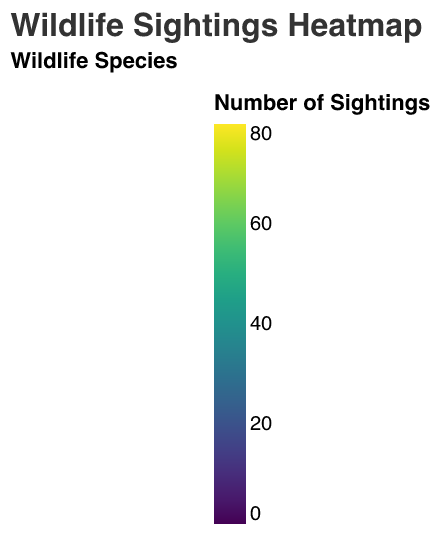What is the title of the heatmap? The title of the heatmap is displayed at the top of the figure in a larger font size, and it typically provides a summary of what the heatmap represents.
Answer: Wildlife Sightings Heatmap Which habitat zone and time of day combination has the highest number of bird sightings? To determine this, look at the bird sightings facet and find the cell with the highest color intensity for birds across all habitat zones and times of day.
Answer: Riverbank, Afternoon What is the total number of squirrel sightings in the Forest Edge habitat zone? Summing the squirrel sightings across all times of day in the Forest Edge zone: 24 (Morning) + 30 (Afternoon) + 20 (Evening) = 74 sightings.
Answer: 74 Which animal has the least number of sightings in the Meadow habitat zone in the morning? In the Meadow habitat zone in the morning, compare the counts for Deer (12), Squirrels (35), Foxes (1), and Birds (30). The least is foxes with 1 sighting.
Answer: Foxes At what time of day does the Wetlands habitat zone have the highest number of bird sightings? In the Wetlands habitat zone, look for the time of day with the highest bird sighting count across Morning, Afternoon, and Evening. The Afternoon has the most sightings with 60.
Answer: Afternoon Compare the total number of deer sightings in the Meadow and Riverbank habitat zones. Which has more? Sum deer sightings across all times of day for both zones. Meadow: 12 (Morning) + 15 (Afternoon) + 20 (Evening) = 47, Riverbank: 6 (Morning) + 9 (Afternoon) + 7 (Evening) = 22. Meadow has more with 47 sightings.
Answer: Meadow What is the average number of fox sightings in the Forest Edge habitat zone? Sum the fox sightings in the Forest Edge (3 Morning + 2 Afternoon + 4 Evening) = 9, then divide by the number of times of day (3) to get the average: 9 / 3 = 3.
Answer: 3 Which habitat zone has the most balanced (close) number of sightings across the different animals during the evening? Assess each zone and calculate the standard deviation of sightings for each animal in the evening. The lower the standard deviation, the more balanced it is. Riverbank has (7 Deer, 14 Squirrels, 3 Foxes, 65 Birds), the standard deviation is low compared to other zones.
Answer: Riverbank What is the difference in bird sightings between the Riverbank and Forest Edge habitats in the afternoon? Subtract the number of bird sightings in the Forest Edge (35) from those in the Riverbank (80) in the afternoon. 80 - 35 = 45.
Answer: 45 In which habitat zone do squirrels have the highest overall frequency of sightings? Sum the squirrel sightings across all times of day for each habitat zone and compare. Forest Edge: 24 + 30 + 20 = 74, Wetlands: 15 + 10 + 18 = 43, Meadow: 35 + 40 + 30 = 105, Riverbank: 12 + 10 + 14 = 36. The Meadow zone has the most with 105 sightings.
Answer: Meadow 